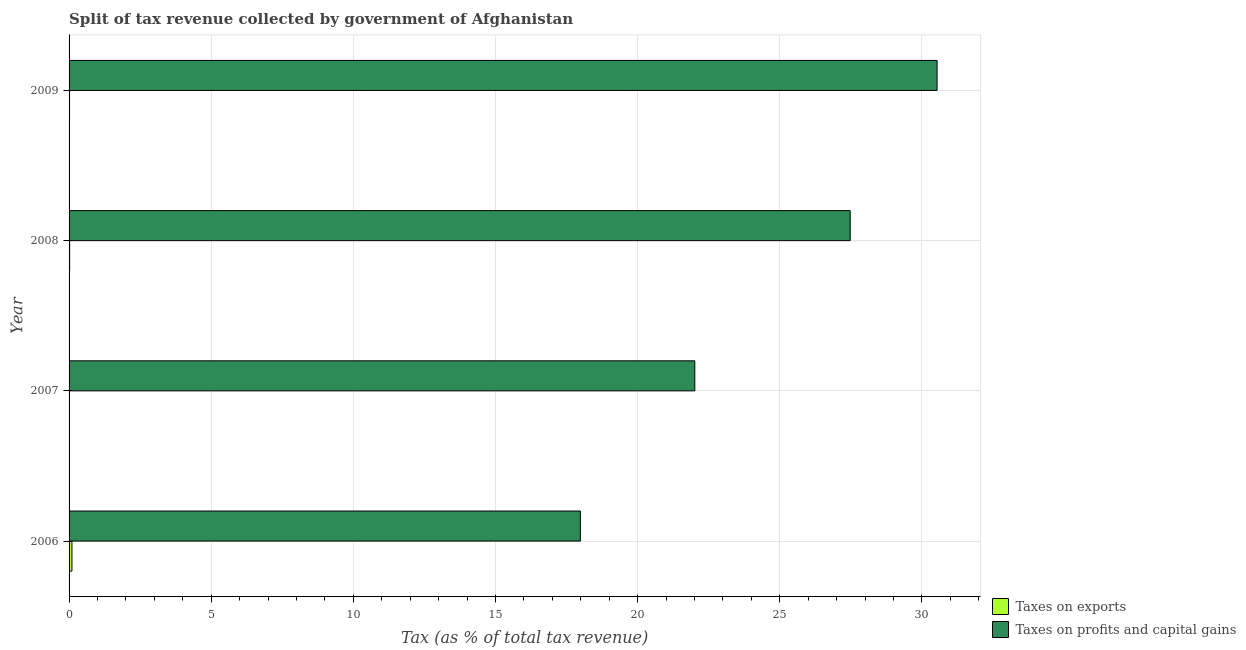Are the number of bars per tick equal to the number of legend labels?
Offer a very short reply. Yes. Are the number of bars on each tick of the Y-axis equal?
Keep it short and to the point. Yes. What is the percentage of revenue obtained from taxes on profits and capital gains in 2007?
Make the answer very short. 22.01. Across all years, what is the maximum percentage of revenue obtained from taxes on exports?
Your answer should be compact. 0.1. Across all years, what is the minimum percentage of revenue obtained from taxes on profits and capital gains?
Make the answer very short. 17.98. What is the total percentage of revenue obtained from taxes on exports in the graph?
Provide a succinct answer. 0.15. What is the difference between the percentage of revenue obtained from taxes on exports in 2006 and that in 2009?
Ensure brevity in your answer.  0.08. What is the difference between the percentage of revenue obtained from taxes on exports in 2008 and the percentage of revenue obtained from taxes on profits and capital gains in 2009?
Your response must be concise. -30.51. What is the average percentage of revenue obtained from taxes on exports per year?
Your answer should be compact. 0.04. In the year 2008, what is the difference between the percentage of revenue obtained from taxes on exports and percentage of revenue obtained from taxes on profits and capital gains?
Provide a succinct answer. -27.46. In how many years, is the percentage of revenue obtained from taxes on exports greater than 3 %?
Give a very brief answer. 0. What is the ratio of the percentage of revenue obtained from taxes on profits and capital gains in 2007 to that in 2008?
Your answer should be very brief. 0.8. Is the percentage of revenue obtained from taxes on profits and capital gains in 2007 less than that in 2008?
Offer a terse response. Yes. What is the difference between the highest and the second highest percentage of revenue obtained from taxes on exports?
Make the answer very short. 0.08. What is the difference between the highest and the lowest percentage of revenue obtained from taxes on exports?
Make the answer very short. 0.09. In how many years, is the percentage of revenue obtained from taxes on exports greater than the average percentage of revenue obtained from taxes on exports taken over all years?
Your answer should be compact. 1. What does the 2nd bar from the top in 2006 represents?
Your answer should be very brief. Taxes on exports. What does the 1st bar from the bottom in 2007 represents?
Offer a terse response. Taxes on exports. How many years are there in the graph?
Your answer should be very brief. 4. What is the difference between two consecutive major ticks on the X-axis?
Your answer should be very brief. 5. Does the graph contain grids?
Give a very brief answer. Yes. How are the legend labels stacked?
Your response must be concise. Vertical. What is the title of the graph?
Your answer should be very brief. Split of tax revenue collected by government of Afghanistan. Does "IMF nonconcessional" appear as one of the legend labels in the graph?
Provide a short and direct response. No. What is the label or title of the X-axis?
Your response must be concise. Tax (as % of total tax revenue). What is the label or title of the Y-axis?
Offer a very short reply. Year. What is the Tax (as % of total tax revenue) in Taxes on exports in 2006?
Keep it short and to the point. 0.1. What is the Tax (as % of total tax revenue) of Taxes on profits and capital gains in 2006?
Offer a very short reply. 17.98. What is the Tax (as % of total tax revenue) of Taxes on exports in 2007?
Provide a succinct answer. 0.01. What is the Tax (as % of total tax revenue) of Taxes on profits and capital gains in 2007?
Offer a terse response. 22.01. What is the Tax (as % of total tax revenue) of Taxes on exports in 2008?
Make the answer very short. 0.02. What is the Tax (as % of total tax revenue) of Taxes on profits and capital gains in 2008?
Offer a very short reply. 27.48. What is the Tax (as % of total tax revenue) of Taxes on exports in 2009?
Keep it short and to the point. 0.02. What is the Tax (as % of total tax revenue) in Taxes on profits and capital gains in 2009?
Make the answer very short. 30.53. Across all years, what is the maximum Tax (as % of total tax revenue) of Taxes on exports?
Your answer should be very brief. 0.1. Across all years, what is the maximum Tax (as % of total tax revenue) in Taxes on profits and capital gains?
Give a very brief answer. 30.53. Across all years, what is the minimum Tax (as % of total tax revenue) of Taxes on exports?
Provide a succinct answer. 0.01. Across all years, what is the minimum Tax (as % of total tax revenue) in Taxes on profits and capital gains?
Your answer should be compact. 17.98. What is the total Tax (as % of total tax revenue) of Taxes on exports in the graph?
Make the answer very short. 0.15. What is the total Tax (as % of total tax revenue) of Taxes on profits and capital gains in the graph?
Provide a short and direct response. 98. What is the difference between the Tax (as % of total tax revenue) in Taxes on exports in 2006 and that in 2007?
Provide a short and direct response. 0.09. What is the difference between the Tax (as % of total tax revenue) in Taxes on profits and capital gains in 2006 and that in 2007?
Give a very brief answer. -4.02. What is the difference between the Tax (as % of total tax revenue) of Taxes on exports in 2006 and that in 2008?
Give a very brief answer. 0.08. What is the difference between the Tax (as % of total tax revenue) of Taxes on profits and capital gains in 2006 and that in 2008?
Offer a terse response. -9.49. What is the difference between the Tax (as % of total tax revenue) of Taxes on exports in 2006 and that in 2009?
Give a very brief answer. 0.08. What is the difference between the Tax (as % of total tax revenue) of Taxes on profits and capital gains in 2006 and that in 2009?
Your response must be concise. -12.55. What is the difference between the Tax (as % of total tax revenue) in Taxes on exports in 2007 and that in 2008?
Your answer should be very brief. -0.01. What is the difference between the Tax (as % of total tax revenue) of Taxes on profits and capital gains in 2007 and that in 2008?
Offer a very short reply. -5.47. What is the difference between the Tax (as % of total tax revenue) of Taxes on exports in 2007 and that in 2009?
Your response must be concise. -0. What is the difference between the Tax (as % of total tax revenue) of Taxes on profits and capital gains in 2007 and that in 2009?
Provide a succinct answer. -8.52. What is the difference between the Tax (as % of total tax revenue) in Taxes on exports in 2008 and that in 2009?
Ensure brevity in your answer.  0. What is the difference between the Tax (as % of total tax revenue) of Taxes on profits and capital gains in 2008 and that in 2009?
Ensure brevity in your answer.  -3.06. What is the difference between the Tax (as % of total tax revenue) of Taxes on exports in 2006 and the Tax (as % of total tax revenue) of Taxes on profits and capital gains in 2007?
Ensure brevity in your answer.  -21.91. What is the difference between the Tax (as % of total tax revenue) in Taxes on exports in 2006 and the Tax (as % of total tax revenue) in Taxes on profits and capital gains in 2008?
Offer a terse response. -27.37. What is the difference between the Tax (as % of total tax revenue) in Taxes on exports in 2006 and the Tax (as % of total tax revenue) in Taxes on profits and capital gains in 2009?
Your answer should be compact. -30.43. What is the difference between the Tax (as % of total tax revenue) of Taxes on exports in 2007 and the Tax (as % of total tax revenue) of Taxes on profits and capital gains in 2008?
Offer a very short reply. -27.46. What is the difference between the Tax (as % of total tax revenue) in Taxes on exports in 2007 and the Tax (as % of total tax revenue) in Taxes on profits and capital gains in 2009?
Offer a very short reply. -30.52. What is the difference between the Tax (as % of total tax revenue) of Taxes on exports in 2008 and the Tax (as % of total tax revenue) of Taxes on profits and capital gains in 2009?
Keep it short and to the point. -30.51. What is the average Tax (as % of total tax revenue) in Taxes on exports per year?
Your answer should be compact. 0.04. What is the average Tax (as % of total tax revenue) in Taxes on profits and capital gains per year?
Offer a terse response. 24.5. In the year 2006, what is the difference between the Tax (as % of total tax revenue) of Taxes on exports and Tax (as % of total tax revenue) of Taxes on profits and capital gains?
Your answer should be very brief. -17.88. In the year 2007, what is the difference between the Tax (as % of total tax revenue) in Taxes on exports and Tax (as % of total tax revenue) in Taxes on profits and capital gains?
Offer a terse response. -22. In the year 2008, what is the difference between the Tax (as % of total tax revenue) in Taxes on exports and Tax (as % of total tax revenue) in Taxes on profits and capital gains?
Provide a succinct answer. -27.46. In the year 2009, what is the difference between the Tax (as % of total tax revenue) in Taxes on exports and Tax (as % of total tax revenue) in Taxes on profits and capital gains?
Your answer should be compact. -30.51. What is the ratio of the Tax (as % of total tax revenue) of Taxes on exports in 2006 to that in 2007?
Offer a very short reply. 7.37. What is the ratio of the Tax (as % of total tax revenue) in Taxes on profits and capital gains in 2006 to that in 2007?
Your answer should be very brief. 0.82. What is the ratio of the Tax (as % of total tax revenue) in Taxes on exports in 2006 to that in 2008?
Give a very brief answer. 5.19. What is the ratio of the Tax (as % of total tax revenue) of Taxes on profits and capital gains in 2006 to that in 2008?
Make the answer very short. 0.65. What is the ratio of the Tax (as % of total tax revenue) of Taxes on exports in 2006 to that in 2009?
Keep it short and to the point. 5.79. What is the ratio of the Tax (as % of total tax revenue) of Taxes on profits and capital gains in 2006 to that in 2009?
Make the answer very short. 0.59. What is the ratio of the Tax (as % of total tax revenue) of Taxes on exports in 2007 to that in 2008?
Your answer should be compact. 0.7. What is the ratio of the Tax (as % of total tax revenue) in Taxes on profits and capital gains in 2007 to that in 2008?
Give a very brief answer. 0.8. What is the ratio of the Tax (as % of total tax revenue) of Taxes on exports in 2007 to that in 2009?
Provide a short and direct response. 0.79. What is the ratio of the Tax (as % of total tax revenue) in Taxes on profits and capital gains in 2007 to that in 2009?
Make the answer very short. 0.72. What is the ratio of the Tax (as % of total tax revenue) of Taxes on exports in 2008 to that in 2009?
Make the answer very short. 1.12. What is the ratio of the Tax (as % of total tax revenue) in Taxes on profits and capital gains in 2008 to that in 2009?
Offer a very short reply. 0.9. What is the difference between the highest and the second highest Tax (as % of total tax revenue) in Taxes on exports?
Your answer should be very brief. 0.08. What is the difference between the highest and the second highest Tax (as % of total tax revenue) of Taxes on profits and capital gains?
Give a very brief answer. 3.06. What is the difference between the highest and the lowest Tax (as % of total tax revenue) of Taxes on exports?
Offer a very short reply. 0.09. What is the difference between the highest and the lowest Tax (as % of total tax revenue) of Taxes on profits and capital gains?
Provide a succinct answer. 12.55. 